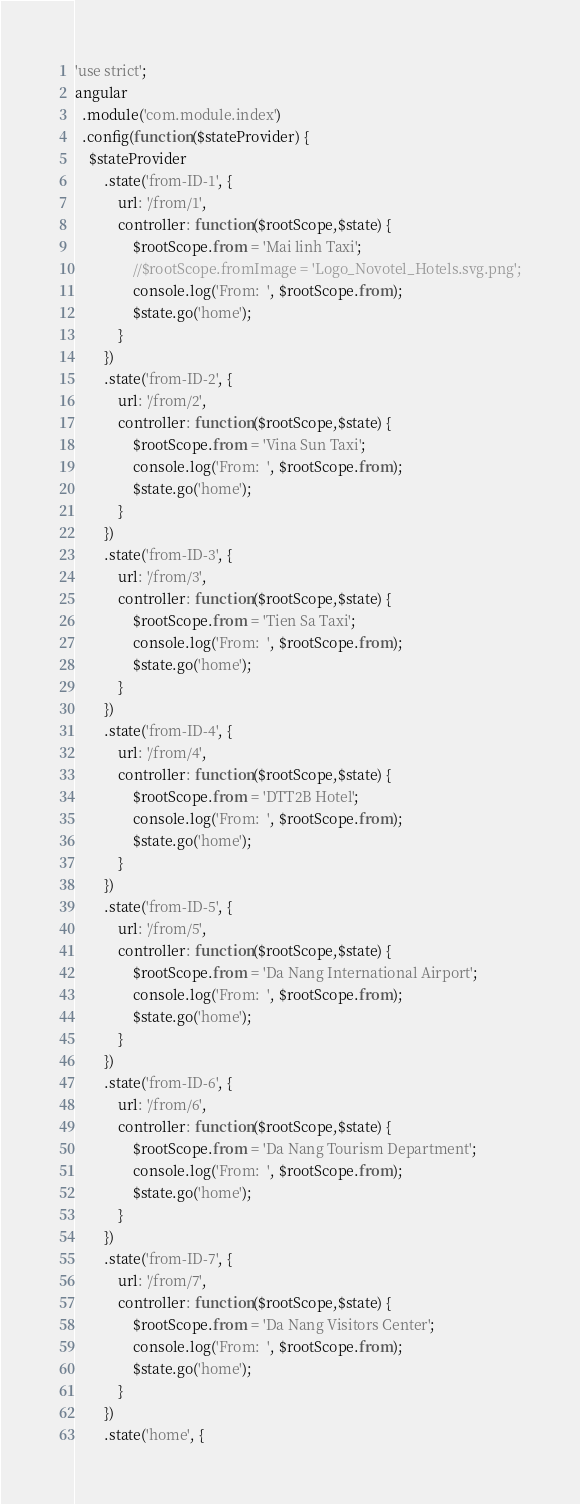Convert code to text. <code><loc_0><loc_0><loc_500><loc_500><_JavaScript_>'use strict';
angular
  .module('com.module.index')
  .config(function($stateProvider) {
    $stateProvider
        .state('from-ID-1', {
            url: '/from/1',
            controller: function($rootScope,$state) {
                $rootScope.from = 'Mai linh Taxi';
                //$rootScope.fromImage = 'Logo_Novotel_Hotels.svg.png';
                console.log('From:  ', $rootScope.from);
                $state.go('home');
            }
        })
        .state('from-ID-2', {
            url: '/from/2',
            controller: function($rootScope,$state) {
                $rootScope.from = 'Vina Sun Taxi';
                console.log('From:  ', $rootScope.from);
                $state.go('home');
            }
        })
        .state('from-ID-3', {
            url: '/from/3',
            controller: function($rootScope,$state) {
                $rootScope.from = 'Tien Sa Taxi';
                console.log('From:  ', $rootScope.from);
                $state.go('home');
            }
        })
        .state('from-ID-4', {
            url: '/from/4',
            controller: function($rootScope,$state) {
                $rootScope.from = 'DTT2B Hotel';
                console.log('From:  ', $rootScope.from);
                $state.go('home');
            }
        })
        .state('from-ID-5', {
            url: '/from/5',
            controller: function($rootScope,$state) {
                $rootScope.from = 'Da Nang International Airport';
                console.log('From:  ', $rootScope.from);
                $state.go('home');
            }
        })
        .state('from-ID-6', {
            url: '/from/6',
            controller: function($rootScope,$state) {
                $rootScope.from = 'Da Nang Tourism Department';
                console.log('From:  ', $rootScope.from);
                $state.go('home');
            }
        })
        .state('from-ID-7', {
            url: '/from/7',
            controller: function($rootScope,$state) {
                $rootScope.from = 'Da Nang Visitors Center';
                console.log('From:  ', $rootScope.from);
                $state.go('home');
            }
        })
      	.state('home', {</code> 